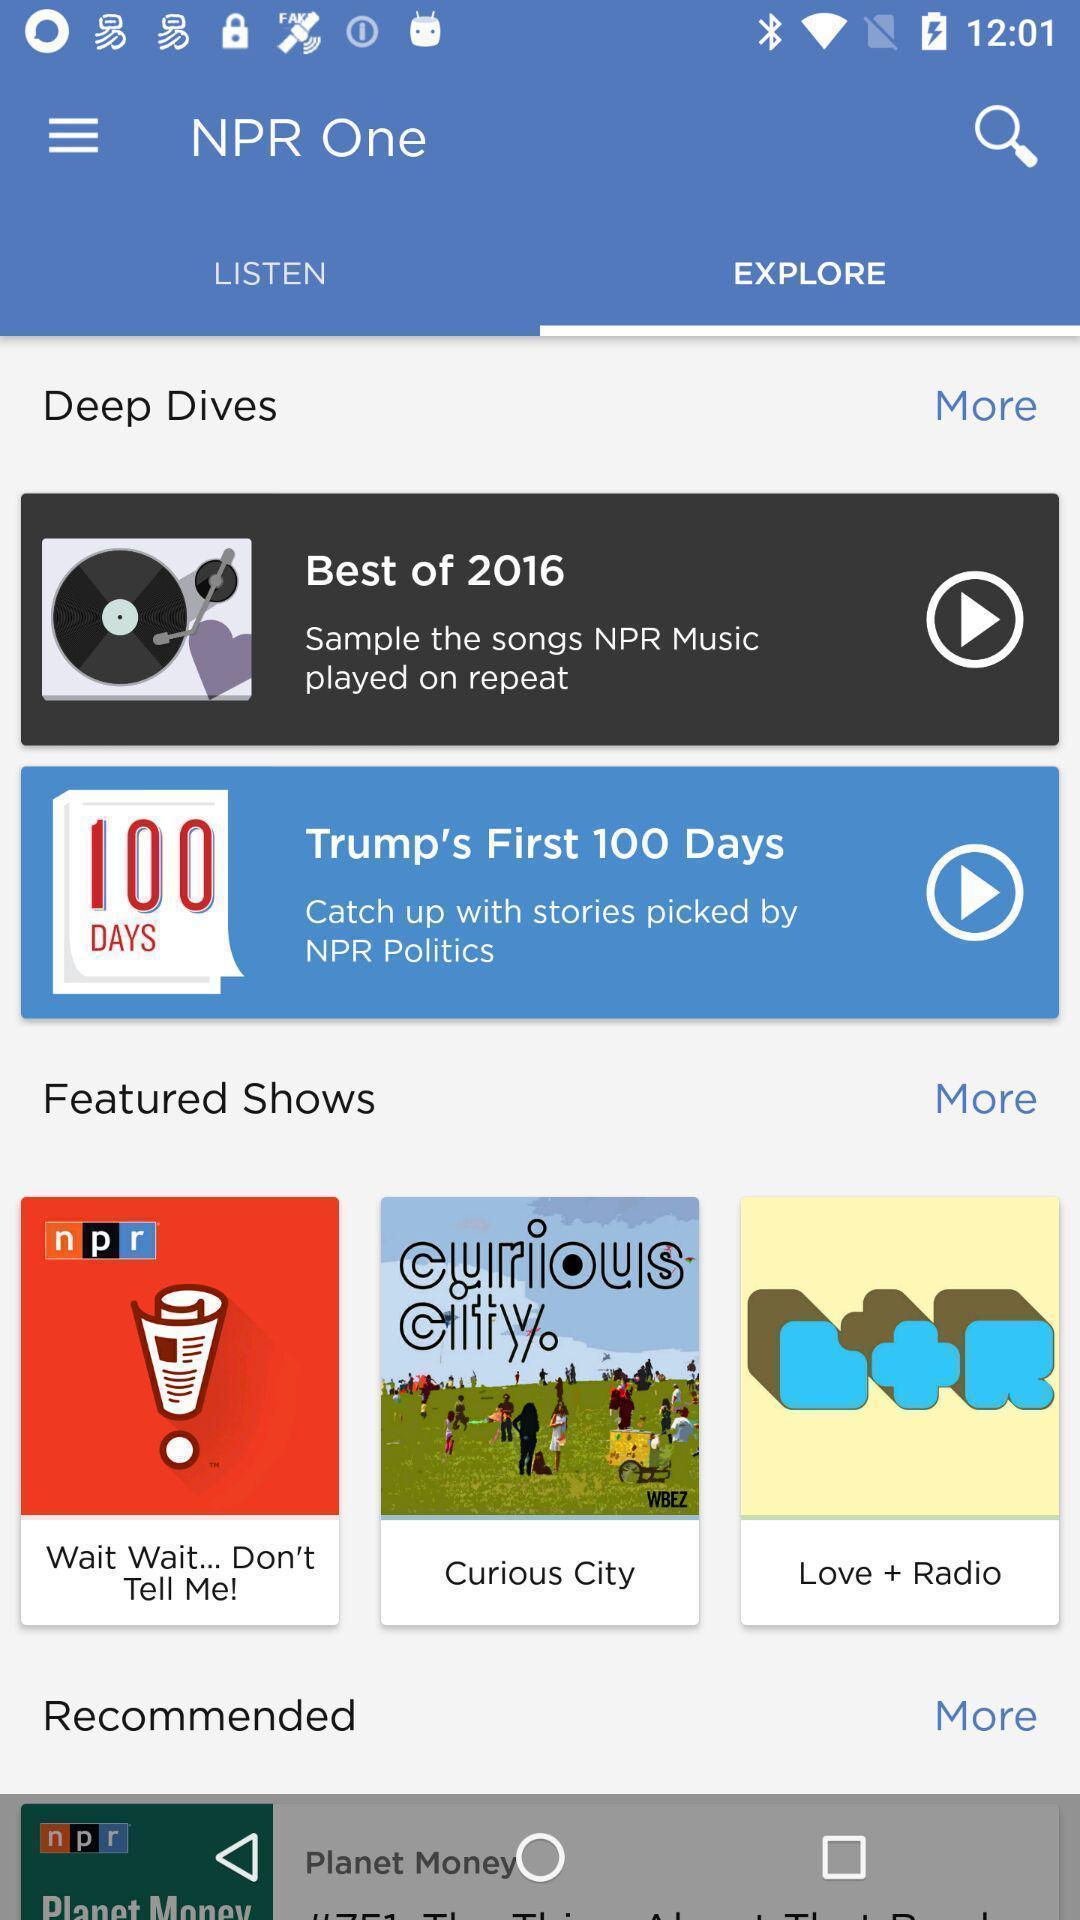What is the overall content of this screenshot? Window displaying a listening app. 